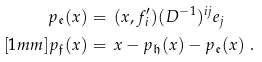Convert formula to latex. <formula><loc_0><loc_0><loc_500><loc_500>p _ { \mathfrak { e } } ( x ) & = \, ( x , f ^ { \prime } _ { i } ) ( D ^ { - 1 } ) ^ { i j } e _ { j } \\ [ 1 m m ] p _ { \mathfrak { f } } ( x ) & = \, x - p _ { \mathfrak { h } } ( x ) - p _ { \mathfrak { e } } ( x ) \ .</formula> 